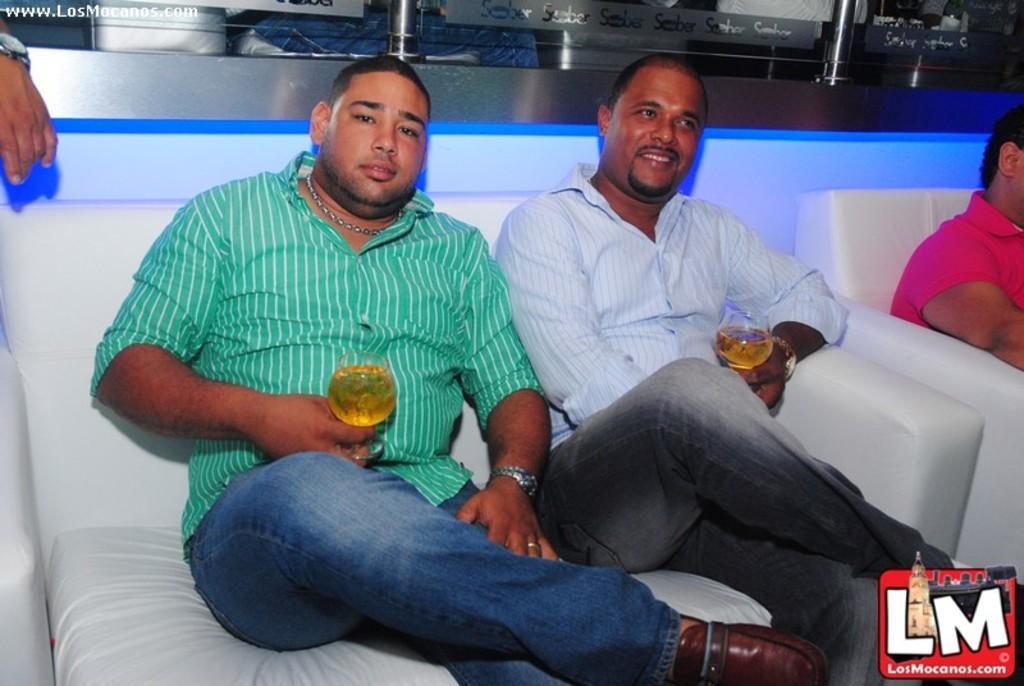Could you give a brief overview of what you see in this image? In this picture we can see people sitting on sofas, two people are holding glasses, on the left side we can see a person hand with watch, here we can see a logo, some text and in the background we can see rods and some objects. 